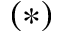Convert formula to latex. <formula><loc_0><loc_0><loc_500><loc_500>( * )</formula> 